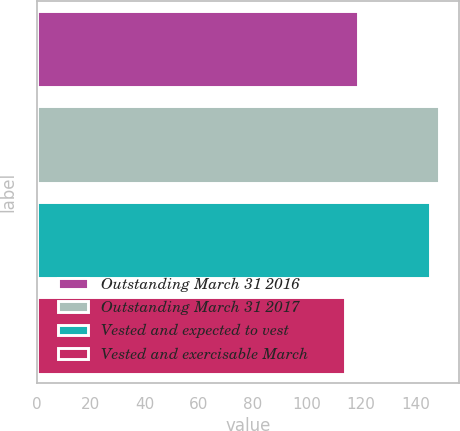Convert chart to OTSL. <chart><loc_0><loc_0><loc_500><loc_500><bar_chart><fcel>Outstanding March 31 2016<fcel>Outstanding March 31 2017<fcel>Vested and expected to vest<fcel>Vested and exercisable March<nl><fcel>118.95<fcel>148.72<fcel>145.54<fcel>114<nl></chart> 